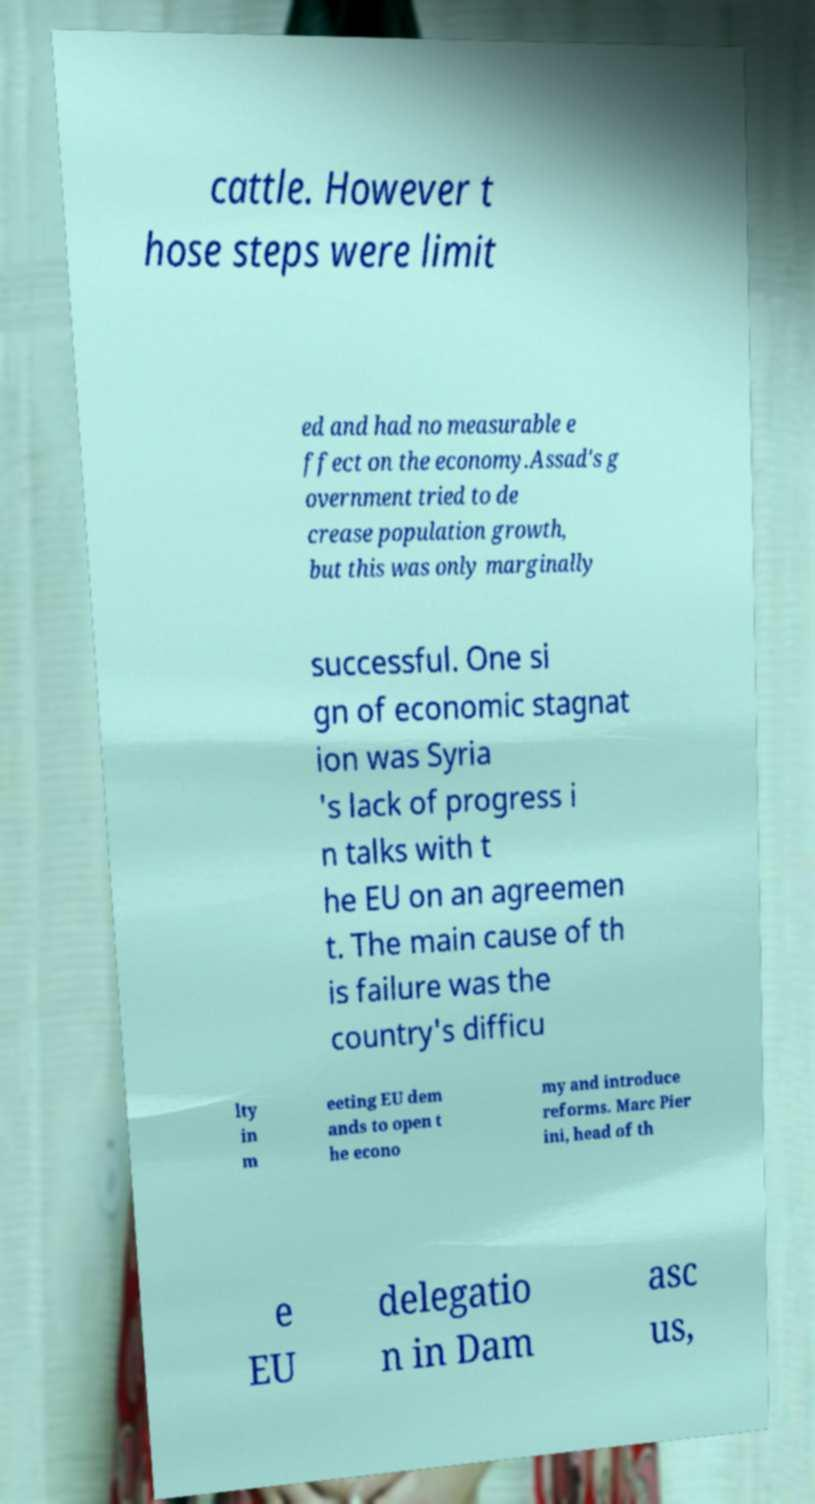There's text embedded in this image that I need extracted. Can you transcribe it verbatim? cattle. However t hose steps were limit ed and had no measurable e ffect on the economy.Assad's g overnment tried to de crease population growth, but this was only marginally successful. One si gn of economic stagnat ion was Syria 's lack of progress i n talks with t he EU on an agreemen t. The main cause of th is failure was the country's difficu lty in m eeting EU dem ands to open t he econo my and introduce reforms. Marc Pier ini, head of th e EU delegatio n in Dam asc us, 